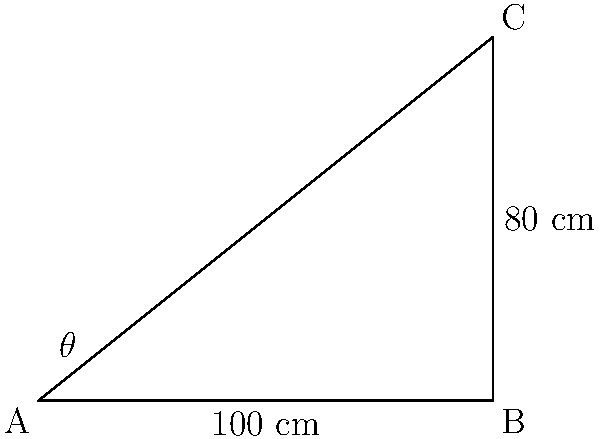Your sibling suggests that the optimal angle for a gaming chair's backrest is related to the "golden angle" in ergonomics. They've set up a chair where the backrest forms a right triangle with the seat and floor. If the seat length is 100 cm and the backrest height is 80 cm, what is the angle of inclination ($\theta$) of the backrest from the horizontal? Round your answer to the nearest degree. To find the angle of inclination ($\theta$), we can use the inverse tangent function (arctangent or $\tan^{-1}$) with the given dimensions of the right triangle:

1. Identify the sides:
   - Adjacent side (seat length) = 100 cm
   - Opposite side (backrest height) = 80 cm

2. Use the tangent function:
   $\tan(\theta) = \frac{\text{opposite}}{\text{adjacent}} = \frac{80}{100} = 0.8$

3. To find $\theta$, we use the inverse tangent:
   $\theta = \tan^{-1}(0.8)$

4. Calculate using a calculator:
   $\theta \approx 38.66°$

5. Round to the nearest degree:
   $\theta \approx 39°$

Thus, the angle of inclination of the backrest from the horizontal is approximately 39°.
Answer: $39°$ 